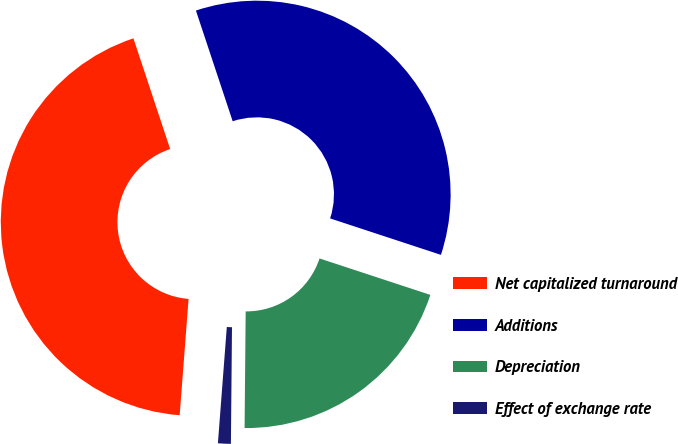Convert chart. <chart><loc_0><loc_0><loc_500><loc_500><pie_chart><fcel>Net capitalized turnaround<fcel>Additions<fcel>Depreciation<fcel>Effect of exchange rate<nl><fcel>43.68%<fcel>35.16%<fcel>20.09%<fcel>1.07%<nl></chart> 